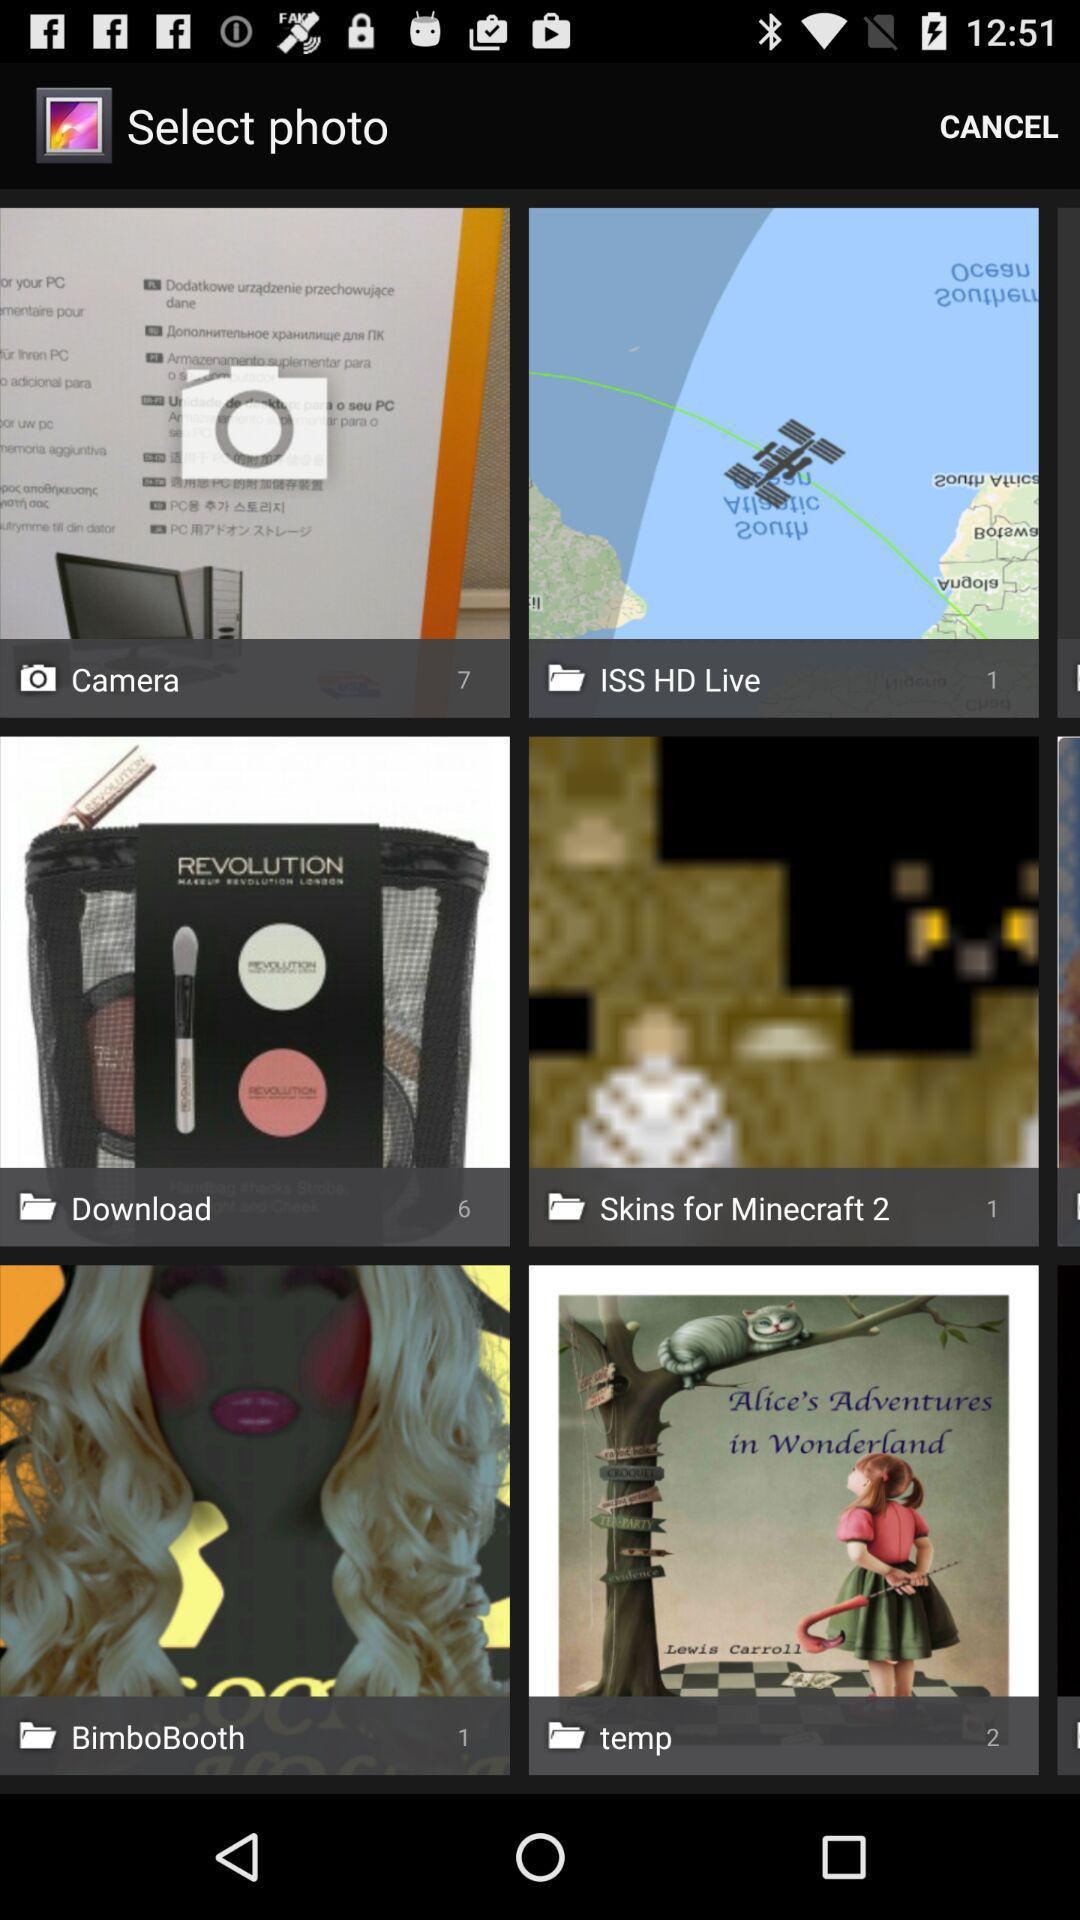What is the number of images in "BimboBooth" album? The number of images is 1. 